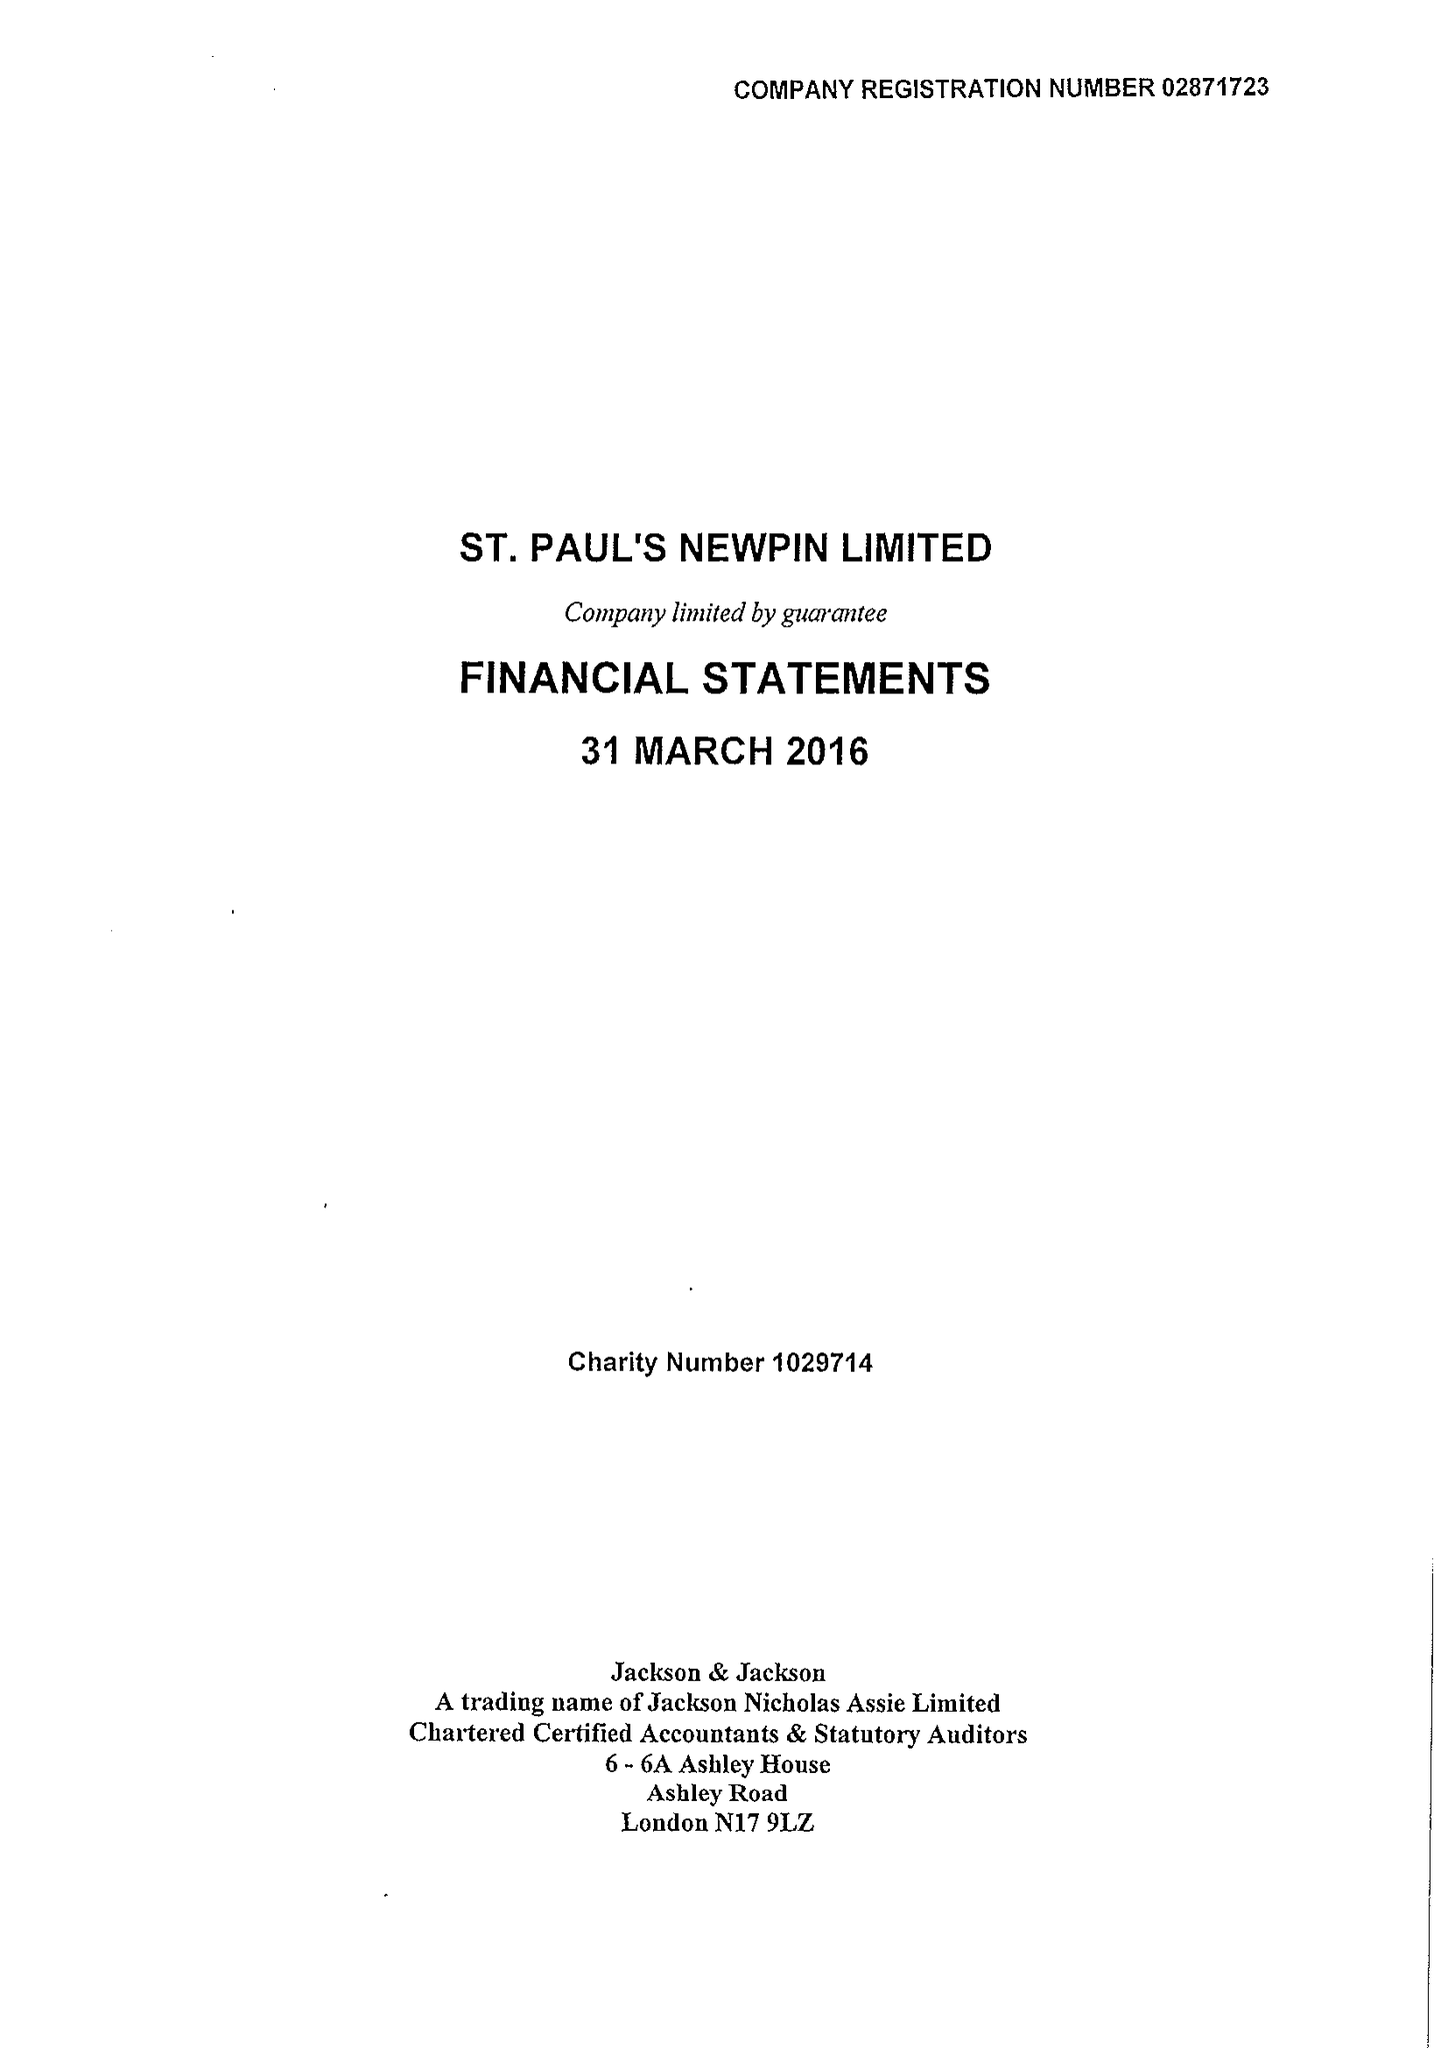What is the value for the charity_number?
Answer the question using a single word or phrase. 1029714 